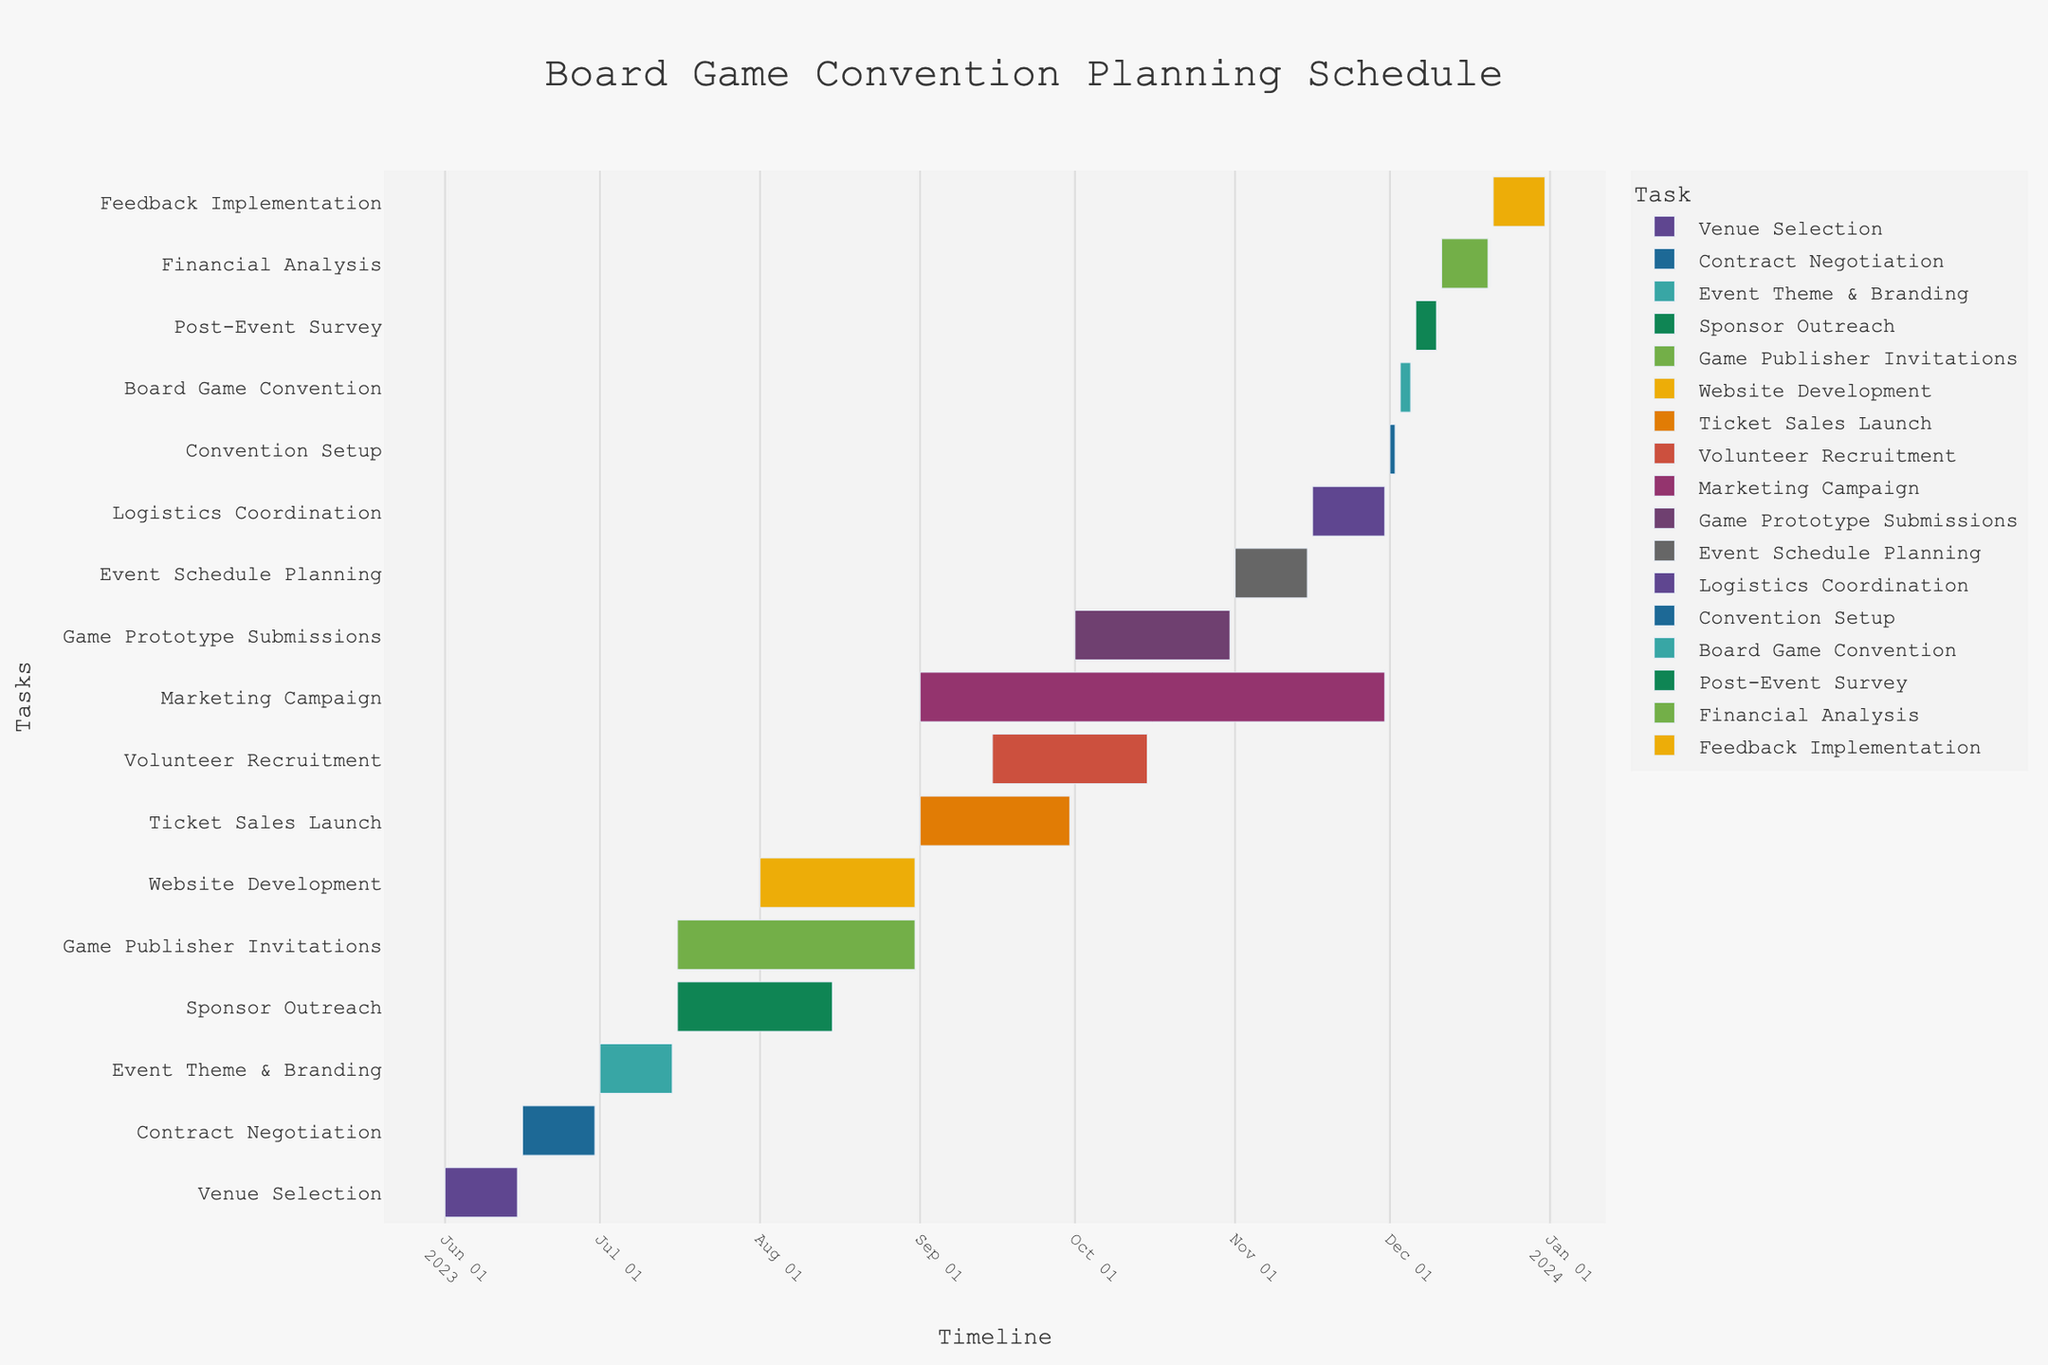What's the title of the figure? The title is usually displayed prominently at the top of the figure. By looking at the top, you can read the title.
Answer: Board Game Convention Planning Schedule What is the duration of the "Venue Selection" task? To find the duration, subtract the start date from the end date for the "Venue Selection" task. The start date is 2023-06-01, and the end date is 2023-06-15. 15 - 1 = 14 days.
Answer: 14 days How long does the "Marketing Campaign" last? For calculating the duration of "Marketing Campaign", subtract the start date from the end date: 2023-09-01 to 2023-11-30. The difference is 90 days.
Answer: 90 days Which task starts immediately after "Event Schedule Planning"? To answer this, look at the end date of "Event Schedule Planning" and find the task that has a start date immediately after. "Event Schedule Planning" ends on 2023-11-15, and "Logistics Coordination" starts on 2023-11-16.
Answer: Logistics Coordination During which dates does the "Board Game Convention" take place? Look for the task named "Board Game Convention" in the figure. The dates are indicated alongside the task.
Answer: 2023-12-03 to 2023-12-05 Which tasks overlap with the "Sponsor Outreach"? Identify the start and end dates of "Sponsor Outreach" (2023-07-16 to 2023-08-15), and then find tasks that have dates falling within this range. Overlapping tasks: "Game Publisher Invitations" and "Website Development".
Answer: Game Publisher Invitations and Website Development Which task has the shortest duration, and how long is it? Scan for tasks with the shortest bar. "Convention Setup" runs from 2023-12-01 to 2023-12-02, which makes it 2 days long.
Answer: Convention Setup, 2 days What is the total duration from the start of "Venue Selection" to the end of "Feedback Implementation"? Find the start date of the first task ("Venue Selection" 2023-06-01) and the end date of the last task ("Feedback Implementation" 2023-12-31). The total duration is from 2023-06-01 to 2023-12-31, which is 214 days.
Answer: 214 days Which two tasks have the most overlap in their timelines? Identify pairs of tasks and compare their start and end dates to see how much their timelines overlap. "Sponsor Outreach" (2023-07-16 to 2023-08-15) and "Game Publisher Invitations" (2023-07-16 to 2023-08-31) overlap significantly, with an overlap of 31 days.
Answer: Sponsor Outreach and Game Publisher Invitations 